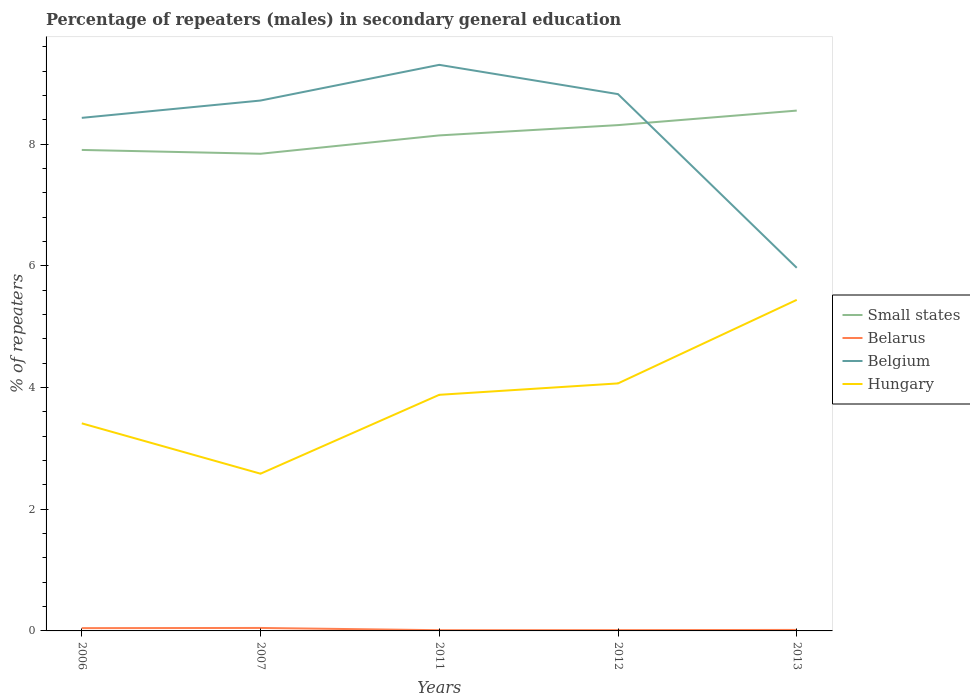Across all years, what is the maximum percentage of male repeaters in Belgium?
Your answer should be very brief. 5.97. In which year was the percentage of male repeaters in Small states maximum?
Make the answer very short. 2007. What is the total percentage of male repeaters in Small states in the graph?
Provide a succinct answer. -0.71. What is the difference between the highest and the second highest percentage of male repeaters in Hungary?
Keep it short and to the point. 2.86. Is the percentage of male repeaters in Belarus strictly greater than the percentage of male repeaters in Belgium over the years?
Ensure brevity in your answer.  Yes. How many lines are there?
Give a very brief answer. 4. What is the difference between two consecutive major ticks on the Y-axis?
Keep it short and to the point. 2. Are the values on the major ticks of Y-axis written in scientific E-notation?
Keep it short and to the point. No. How are the legend labels stacked?
Your response must be concise. Vertical. What is the title of the graph?
Ensure brevity in your answer.  Percentage of repeaters (males) in secondary general education. Does "Lao PDR" appear as one of the legend labels in the graph?
Your response must be concise. No. What is the label or title of the X-axis?
Give a very brief answer. Years. What is the label or title of the Y-axis?
Your response must be concise. % of repeaters. What is the % of repeaters in Small states in 2006?
Offer a terse response. 7.9. What is the % of repeaters of Belarus in 2006?
Offer a terse response. 0.05. What is the % of repeaters in Belgium in 2006?
Make the answer very short. 8.43. What is the % of repeaters of Hungary in 2006?
Give a very brief answer. 3.41. What is the % of repeaters in Small states in 2007?
Give a very brief answer. 7.84. What is the % of repeaters of Belarus in 2007?
Make the answer very short. 0.05. What is the % of repeaters of Belgium in 2007?
Offer a very short reply. 8.72. What is the % of repeaters of Hungary in 2007?
Provide a succinct answer. 2.58. What is the % of repeaters in Small states in 2011?
Keep it short and to the point. 8.14. What is the % of repeaters in Belarus in 2011?
Provide a succinct answer. 0.01. What is the % of repeaters of Belgium in 2011?
Give a very brief answer. 9.3. What is the % of repeaters of Hungary in 2011?
Provide a short and direct response. 3.88. What is the % of repeaters of Small states in 2012?
Provide a short and direct response. 8.31. What is the % of repeaters of Belarus in 2012?
Your response must be concise. 0.01. What is the % of repeaters of Belgium in 2012?
Your answer should be compact. 8.82. What is the % of repeaters in Hungary in 2012?
Offer a very short reply. 4.07. What is the % of repeaters of Small states in 2013?
Your answer should be very brief. 8.55. What is the % of repeaters in Belarus in 2013?
Offer a very short reply. 0.02. What is the % of repeaters in Belgium in 2013?
Your response must be concise. 5.97. What is the % of repeaters in Hungary in 2013?
Provide a succinct answer. 5.44. Across all years, what is the maximum % of repeaters in Small states?
Give a very brief answer. 8.55. Across all years, what is the maximum % of repeaters of Belarus?
Keep it short and to the point. 0.05. Across all years, what is the maximum % of repeaters of Belgium?
Your answer should be very brief. 9.3. Across all years, what is the maximum % of repeaters of Hungary?
Your response must be concise. 5.44. Across all years, what is the minimum % of repeaters of Small states?
Provide a succinct answer. 7.84. Across all years, what is the minimum % of repeaters of Belarus?
Your answer should be very brief. 0.01. Across all years, what is the minimum % of repeaters of Belgium?
Give a very brief answer. 5.97. Across all years, what is the minimum % of repeaters of Hungary?
Provide a short and direct response. 2.58. What is the total % of repeaters of Small states in the graph?
Offer a very short reply. 40.75. What is the total % of repeaters of Belarus in the graph?
Make the answer very short. 0.14. What is the total % of repeaters in Belgium in the graph?
Provide a short and direct response. 41.24. What is the total % of repeaters in Hungary in the graph?
Your response must be concise. 19.38. What is the difference between the % of repeaters of Small states in 2006 and that in 2007?
Your response must be concise. 0.06. What is the difference between the % of repeaters in Belarus in 2006 and that in 2007?
Your answer should be compact. -0. What is the difference between the % of repeaters of Belgium in 2006 and that in 2007?
Provide a short and direct response. -0.28. What is the difference between the % of repeaters of Hungary in 2006 and that in 2007?
Offer a terse response. 0.83. What is the difference between the % of repeaters of Small states in 2006 and that in 2011?
Offer a very short reply. -0.24. What is the difference between the % of repeaters of Belarus in 2006 and that in 2011?
Provide a short and direct response. 0.03. What is the difference between the % of repeaters in Belgium in 2006 and that in 2011?
Make the answer very short. -0.87. What is the difference between the % of repeaters of Hungary in 2006 and that in 2011?
Offer a very short reply. -0.47. What is the difference between the % of repeaters of Small states in 2006 and that in 2012?
Provide a short and direct response. -0.41. What is the difference between the % of repeaters of Belarus in 2006 and that in 2012?
Offer a very short reply. 0.03. What is the difference between the % of repeaters of Belgium in 2006 and that in 2012?
Your response must be concise. -0.39. What is the difference between the % of repeaters of Hungary in 2006 and that in 2012?
Your answer should be compact. -0.66. What is the difference between the % of repeaters in Small states in 2006 and that in 2013?
Provide a succinct answer. -0.65. What is the difference between the % of repeaters of Belarus in 2006 and that in 2013?
Your answer should be compact. 0.03. What is the difference between the % of repeaters in Belgium in 2006 and that in 2013?
Provide a succinct answer. 2.46. What is the difference between the % of repeaters in Hungary in 2006 and that in 2013?
Your answer should be very brief. -2.03. What is the difference between the % of repeaters in Small states in 2007 and that in 2011?
Offer a terse response. -0.3. What is the difference between the % of repeaters in Belarus in 2007 and that in 2011?
Provide a short and direct response. 0.04. What is the difference between the % of repeaters in Belgium in 2007 and that in 2011?
Keep it short and to the point. -0.59. What is the difference between the % of repeaters in Hungary in 2007 and that in 2011?
Offer a terse response. -1.3. What is the difference between the % of repeaters in Small states in 2007 and that in 2012?
Provide a short and direct response. -0.47. What is the difference between the % of repeaters in Belarus in 2007 and that in 2012?
Provide a short and direct response. 0.04. What is the difference between the % of repeaters of Belgium in 2007 and that in 2012?
Your response must be concise. -0.11. What is the difference between the % of repeaters of Hungary in 2007 and that in 2012?
Give a very brief answer. -1.48. What is the difference between the % of repeaters of Small states in 2007 and that in 2013?
Provide a succinct answer. -0.71. What is the difference between the % of repeaters of Belarus in 2007 and that in 2013?
Your answer should be very brief. 0.03. What is the difference between the % of repeaters in Belgium in 2007 and that in 2013?
Ensure brevity in your answer.  2.75. What is the difference between the % of repeaters of Hungary in 2007 and that in 2013?
Provide a succinct answer. -2.86. What is the difference between the % of repeaters of Small states in 2011 and that in 2012?
Provide a short and direct response. -0.17. What is the difference between the % of repeaters of Belarus in 2011 and that in 2012?
Your answer should be compact. -0. What is the difference between the % of repeaters of Belgium in 2011 and that in 2012?
Provide a short and direct response. 0.48. What is the difference between the % of repeaters of Hungary in 2011 and that in 2012?
Keep it short and to the point. -0.19. What is the difference between the % of repeaters in Small states in 2011 and that in 2013?
Your response must be concise. -0.41. What is the difference between the % of repeaters of Belarus in 2011 and that in 2013?
Your answer should be very brief. -0. What is the difference between the % of repeaters in Belgium in 2011 and that in 2013?
Make the answer very short. 3.34. What is the difference between the % of repeaters of Hungary in 2011 and that in 2013?
Your answer should be very brief. -1.56. What is the difference between the % of repeaters of Small states in 2012 and that in 2013?
Give a very brief answer. -0.24. What is the difference between the % of repeaters of Belarus in 2012 and that in 2013?
Ensure brevity in your answer.  -0. What is the difference between the % of repeaters in Belgium in 2012 and that in 2013?
Your response must be concise. 2.85. What is the difference between the % of repeaters of Hungary in 2012 and that in 2013?
Your response must be concise. -1.37. What is the difference between the % of repeaters of Small states in 2006 and the % of repeaters of Belarus in 2007?
Provide a succinct answer. 7.86. What is the difference between the % of repeaters of Small states in 2006 and the % of repeaters of Belgium in 2007?
Provide a short and direct response. -0.81. What is the difference between the % of repeaters of Small states in 2006 and the % of repeaters of Hungary in 2007?
Your response must be concise. 5.32. What is the difference between the % of repeaters in Belarus in 2006 and the % of repeaters in Belgium in 2007?
Offer a very short reply. -8.67. What is the difference between the % of repeaters in Belarus in 2006 and the % of repeaters in Hungary in 2007?
Your response must be concise. -2.54. What is the difference between the % of repeaters in Belgium in 2006 and the % of repeaters in Hungary in 2007?
Keep it short and to the point. 5.85. What is the difference between the % of repeaters in Small states in 2006 and the % of repeaters in Belarus in 2011?
Your answer should be very brief. 7.89. What is the difference between the % of repeaters of Small states in 2006 and the % of repeaters of Belgium in 2011?
Provide a short and direct response. -1.4. What is the difference between the % of repeaters in Small states in 2006 and the % of repeaters in Hungary in 2011?
Make the answer very short. 4.02. What is the difference between the % of repeaters of Belarus in 2006 and the % of repeaters of Belgium in 2011?
Offer a terse response. -9.26. What is the difference between the % of repeaters of Belarus in 2006 and the % of repeaters of Hungary in 2011?
Your answer should be very brief. -3.83. What is the difference between the % of repeaters of Belgium in 2006 and the % of repeaters of Hungary in 2011?
Give a very brief answer. 4.55. What is the difference between the % of repeaters in Small states in 2006 and the % of repeaters in Belarus in 2012?
Your response must be concise. 7.89. What is the difference between the % of repeaters of Small states in 2006 and the % of repeaters of Belgium in 2012?
Provide a short and direct response. -0.92. What is the difference between the % of repeaters in Small states in 2006 and the % of repeaters in Hungary in 2012?
Provide a short and direct response. 3.84. What is the difference between the % of repeaters of Belarus in 2006 and the % of repeaters of Belgium in 2012?
Offer a terse response. -8.78. What is the difference between the % of repeaters in Belarus in 2006 and the % of repeaters in Hungary in 2012?
Your response must be concise. -4.02. What is the difference between the % of repeaters of Belgium in 2006 and the % of repeaters of Hungary in 2012?
Your response must be concise. 4.36. What is the difference between the % of repeaters in Small states in 2006 and the % of repeaters in Belarus in 2013?
Provide a short and direct response. 7.89. What is the difference between the % of repeaters of Small states in 2006 and the % of repeaters of Belgium in 2013?
Provide a succinct answer. 1.94. What is the difference between the % of repeaters of Small states in 2006 and the % of repeaters of Hungary in 2013?
Offer a very short reply. 2.46. What is the difference between the % of repeaters of Belarus in 2006 and the % of repeaters of Belgium in 2013?
Provide a short and direct response. -5.92. What is the difference between the % of repeaters in Belarus in 2006 and the % of repeaters in Hungary in 2013?
Offer a terse response. -5.39. What is the difference between the % of repeaters of Belgium in 2006 and the % of repeaters of Hungary in 2013?
Your response must be concise. 2.99. What is the difference between the % of repeaters of Small states in 2007 and the % of repeaters of Belarus in 2011?
Provide a succinct answer. 7.83. What is the difference between the % of repeaters of Small states in 2007 and the % of repeaters of Belgium in 2011?
Ensure brevity in your answer.  -1.46. What is the difference between the % of repeaters in Small states in 2007 and the % of repeaters in Hungary in 2011?
Your answer should be very brief. 3.96. What is the difference between the % of repeaters in Belarus in 2007 and the % of repeaters in Belgium in 2011?
Ensure brevity in your answer.  -9.25. What is the difference between the % of repeaters in Belarus in 2007 and the % of repeaters in Hungary in 2011?
Your response must be concise. -3.83. What is the difference between the % of repeaters in Belgium in 2007 and the % of repeaters in Hungary in 2011?
Your answer should be compact. 4.84. What is the difference between the % of repeaters in Small states in 2007 and the % of repeaters in Belarus in 2012?
Your response must be concise. 7.83. What is the difference between the % of repeaters in Small states in 2007 and the % of repeaters in Belgium in 2012?
Your response must be concise. -0.98. What is the difference between the % of repeaters of Small states in 2007 and the % of repeaters of Hungary in 2012?
Your answer should be compact. 3.77. What is the difference between the % of repeaters in Belarus in 2007 and the % of repeaters in Belgium in 2012?
Make the answer very short. -8.77. What is the difference between the % of repeaters of Belarus in 2007 and the % of repeaters of Hungary in 2012?
Your answer should be compact. -4.02. What is the difference between the % of repeaters of Belgium in 2007 and the % of repeaters of Hungary in 2012?
Keep it short and to the point. 4.65. What is the difference between the % of repeaters of Small states in 2007 and the % of repeaters of Belarus in 2013?
Your answer should be very brief. 7.82. What is the difference between the % of repeaters in Small states in 2007 and the % of repeaters in Belgium in 2013?
Provide a short and direct response. 1.87. What is the difference between the % of repeaters of Small states in 2007 and the % of repeaters of Hungary in 2013?
Keep it short and to the point. 2.4. What is the difference between the % of repeaters in Belarus in 2007 and the % of repeaters in Belgium in 2013?
Provide a short and direct response. -5.92. What is the difference between the % of repeaters of Belarus in 2007 and the % of repeaters of Hungary in 2013?
Offer a terse response. -5.39. What is the difference between the % of repeaters in Belgium in 2007 and the % of repeaters in Hungary in 2013?
Your answer should be compact. 3.28. What is the difference between the % of repeaters in Small states in 2011 and the % of repeaters in Belarus in 2012?
Your answer should be compact. 8.13. What is the difference between the % of repeaters of Small states in 2011 and the % of repeaters of Belgium in 2012?
Your answer should be compact. -0.68. What is the difference between the % of repeaters in Small states in 2011 and the % of repeaters in Hungary in 2012?
Your answer should be compact. 4.08. What is the difference between the % of repeaters in Belarus in 2011 and the % of repeaters in Belgium in 2012?
Your answer should be compact. -8.81. What is the difference between the % of repeaters in Belarus in 2011 and the % of repeaters in Hungary in 2012?
Provide a succinct answer. -4.06. What is the difference between the % of repeaters in Belgium in 2011 and the % of repeaters in Hungary in 2012?
Your response must be concise. 5.23. What is the difference between the % of repeaters in Small states in 2011 and the % of repeaters in Belarus in 2013?
Ensure brevity in your answer.  8.13. What is the difference between the % of repeaters of Small states in 2011 and the % of repeaters of Belgium in 2013?
Your answer should be compact. 2.18. What is the difference between the % of repeaters of Small states in 2011 and the % of repeaters of Hungary in 2013?
Offer a terse response. 2.7. What is the difference between the % of repeaters of Belarus in 2011 and the % of repeaters of Belgium in 2013?
Offer a terse response. -5.96. What is the difference between the % of repeaters of Belarus in 2011 and the % of repeaters of Hungary in 2013?
Give a very brief answer. -5.43. What is the difference between the % of repeaters of Belgium in 2011 and the % of repeaters of Hungary in 2013?
Your answer should be compact. 3.86. What is the difference between the % of repeaters in Small states in 2012 and the % of repeaters in Belarus in 2013?
Keep it short and to the point. 8.3. What is the difference between the % of repeaters in Small states in 2012 and the % of repeaters in Belgium in 2013?
Give a very brief answer. 2.34. What is the difference between the % of repeaters in Small states in 2012 and the % of repeaters in Hungary in 2013?
Give a very brief answer. 2.87. What is the difference between the % of repeaters of Belarus in 2012 and the % of repeaters of Belgium in 2013?
Ensure brevity in your answer.  -5.95. What is the difference between the % of repeaters of Belarus in 2012 and the % of repeaters of Hungary in 2013?
Offer a terse response. -5.43. What is the difference between the % of repeaters of Belgium in 2012 and the % of repeaters of Hungary in 2013?
Ensure brevity in your answer.  3.38. What is the average % of repeaters of Small states per year?
Your response must be concise. 8.15. What is the average % of repeaters of Belarus per year?
Keep it short and to the point. 0.03. What is the average % of repeaters of Belgium per year?
Offer a very short reply. 8.25. What is the average % of repeaters of Hungary per year?
Give a very brief answer. 3.88. In the year 2006, what is the difference between the % of repeaters in Small states and % of repeaters in Belarus?
Give a very brief answer. 7.86. In the year 2006, what is the difference between the % of repeaters of Small states and % of repeaters of Belgium?
Ensure brevity in your answer.  -0.53. In the year 2006, what is the difference between the % of repeaters of Small states and % of repeaters of Hungary?
Your answer should be very brief. 4.49. In the year 2006, what is the difference between the % of repeaters in Belarus and % of repeaters in Belgium?
Your answer should be compact. -8.39. In the year 2006, what is the difference between the % of repeaters of Belarus and % of repeaters of Hungary?
Provide a succinct answer. -3.37. In the year 2006, what is the difference between the % of repeaters of Belgium and % of repeaters of Hungary?
Provide a succinct answer. 5.02. In the year 2007, what is the difference between the % of repeaters in Small states and % of repeaters in Belarus?
Give a very brief answer. 7.79. In the year 2007, what is the difference between the % of repeaters of Small states and % of repeaters of Belgium?
Offer a terse response. -0.87. In the year 2007, what is the difference between the % of repeaters in Small states and % of repeaters in Hungary?
Offer a terse response. 5.26. In the year 2007, what is the difference between the % of repeaters in Belarus and % of repeaters in Belgium?
Give a very brief answer. -8.67. In the year 2007, what is the difference between the % of repeaters of Belarus and % of repeaters of Hungary?
Your response must be concise. -2.54. In the year 2007, what is the difference between the % of repeaters in Belgium and % of repeaters in Hungary?
Your response must be concise. 6.13. In the year 2011, what is the difference between the % of repeaters of Small states and % of repeaters of Belarus?
Your answer should be very brief. 8.13. In the year 2011, what is the difference between the % of repeaters of Small states and % of repeaters of Belgium?
Offer a terse response. -1.16. In the year 2011, what is the difference between the % of repeaters of Small states and % of repeaters of Hungary?
Keep it short and to the point. 4.26. In the year 2011, what is the difference between the % of repeaters in Belarus and % of repeaters in Belgium?
Your answer should be compact. -9.29. In the year 2011, what is the difference between the % of repeaters in Belarus and % of repeaters in Hungary?
Ensure brevity in your answer.  -3.87. In the year 2011, what is the difference between the % of repeaters in Belgium and % of repeaters in Hungary?
Offer a very short reply. 5.42. In the year 2012, what is the difference between the % of repeaters in Small states and % of repeaters in Belarus?
Your answer should be compact. 8.3. In the year 2012, what is the difference between the % of repeaters of Small states and % of repeaters of Belgium?
Provide a succinct answer. -0.51. In the year 2012, what is the difference between the % of repeaters in Small states and % of repeaters in Hungary?
Your answer should be compact. 4.24. In the year 2012, what is the difference between the % of repeaters in Belarus and % of repeaters in Belgium?
Your response must be concise. -8.81. In the year 2012, what is the difference between the % of repeaters of Belarus and % of repeaters of Hungary?
Keep it short and to the point. -4.05. In the year 2012, what is the difference between the % of repeaters in Belgium and % of repeaters in Hungary?
Ensure brevity in your answer.  4.75. In the year 2013, what is the difference between the % of repeaters in Small states and % of repeaters in Belarus?
Offer a terse response. 8.53. In the year 2013, what is the difference between the % of repeaters in Small states and % of repeaters in Belgium?
Your response must be concise. 2.58. In the year 2013, what is the difference between the % of repeaters of Small states and % of repeaters of Hungary?
Your answer should be compact. 3.11. In the year 2013, what is the difference between the % of repeaters of Belarus and % of repeaters of Belgium?
Provide a succinct answer. -5.95. In the year 2013, what is the difference between the % of repeaters in Belarus and % of repeaters in Hungary?
Your answer should be very brief. -5.42. In the year 2013, what is the difference between the % of repeaters of Belgium and % of repeaters of Hungary?
Ensure brevity in your answer.  0.53. What is the ratio of the % of repeaters in Belarus in 2006 to that in 2007?
Provide a succinct answer. 0.94. What is the ratio of the % of repeaters of Belgium in 2006 to that in 2007?
Provide a short and direct response. 0.97. What is the ratio of the % of repeaters of Hungary in 2006 to that in 2007?
Give a very brief answer. 1.32. What is the ratio of the % of repeaters of Small states in 2006 to that in 2011?
Provide a short and direct response. 0.97. What is the ratio of the % of repeaters in Belarus in 2006 to that in 2011?
Keep it short and to the point. 3.91. What is the ratio of the % of repeaters of Belgium in 2006 to that in 2011?
Your answer should be very brief. 0.91. What is the ratio of the % of repeaters in Hungary in 2006 to that in 2011?
Make the answer very short. 0.88. What is the ratio of the % of repeaters of Small states in 2006 to that in 2012?
Make the answer very short. 0.95. What is the ratio of the % of repeaters of Belarus in 2006 to that in 2012?
Give a very brief answer. 3.57. What is the ratio of the % of repeaters of Belgium in 2006 to that in 2012?
Your answer should be very brief. 0.96. What is the ratio of the % of repeaters of Hungary in 2006 to that in 2012?
Offer a very short reply. 0.84. What is the ratio of the % of repeaters in Small states in 2006 to that in 2013?
Offer a terse response. 0.92. What is the ratio of the % of repeaters in Belarus in 2006 to that in 2013?
Your response must be concise. 2.82. What is the ratio of the % of repeaters of Belgium in 2006 to that in 2013?
Your answer should be very brief. 1.41. What is the ratio of the % of repeaters in Hungary in 2006 to that in 2013?
Provide a short and direct response. 0.63. What is the ratio of the % of repeaters in Belarus in 2007 to that in 2011?
Ensure brevity in your answer.  4.14. What is the ratio of the % of repeaters in Belgium in 2007 to that in 2011?
Your answer should be very brief. 0.94. What is the ratio of the % of repeaters in Hungary in 2007 to that in 2011?
Provide a succinct answer. 0.67. What is the ratio of the % of repeaters of Small states in 2007 to that in 2012?
Provide a short and direct response. 0.94. What is the ratio of the % of repeaters in Belarus in 2007 to that in 2012?
Your answer should be very brief. 3.78. What is the ratio of the % of repeaters in Hungary in 2007 to that in 2012?
Keep it short and to the point. 0.64. What is the ratio of the % of repeaters in Small states in 2007 to that in 2013?
Provide a short and direct response. 0.92. What is the ratio of the % of repeaters in Belarus in 2007 to that in 2013?
Provide a succinct answer. 2.98. What is the ratio of the % of repeaters in Belgium in 2007 to that in 2013?
Ensure brevity in your answer.  1.46. What is the ratio of the % of repeaters in Hungary in 2007 to that in 2013?
Your answer should be very brief. 0.47. What is the ratio of the % of repeaters of Small states in 2011 to that in 2012?
Ensure brevity in your answer.  0.98. What is the ratio of the % of repeaters in Belarus in 2011 to that in 2012?
Ensure brevity in your answer.  0.91. What is the ratio of the % of repeaters in Belgium in 2011 to that in 2012?
Ensure brevity in your answer.  1.05. What is the ratio of the % of repeaters of Hungary in 2011 to that in 2012?
Offer a terse response. 0.95. What is the ratio of the % of repeaters in Small states in 2011 to that in 2013?
Make the answer very short. 0.95. What is the ratio of the % of repeaters of Belarus in 2011 to that in 2013?
Make the answer very short. 0.72. What is the ratio of the % of repeaters of Belgium in 2011 to that in 2013?
Your response must be concise. 1.56. What is the ratio of the % of repeaters in Hungary in 2011 to that in 2013?
Your answer should be very brief. 0.71. What is the ratio of the % of repeaters in Small states in 2012 to that in 2013?
Give a very brief answer. 0.97. What is the ratio of the % of repeaters of Belarus in 2012 to that in 2013?
Keep it short and to the point. 0.79. What is the ratio of the % of repeaters in Belgium in 2012 to that in 2013?
Offer a terse response. 1.48. What is the ratio of the % of repeaters of Hungary in 2012 to that in 2013?
Provide a succinct answer. 0.75. What is the difference between the highest and the second highest % of repeaters in Small states?
Offer a very short reply. 0.24. What is the difference between the highest and the second highest % of repeaters of Belarus?
Offer a terse response. 0. What is the difference between the highest and the second highest % of repeaters of Belgium?
Provide a succinct answer. 0.48. What is the difference between the highest and the second highest % of repeaters of Hungary?
Offer a very short reply. 1.37. What is the difference between the highest and the lowest % of repeaters in Small states?
Your response must be concise. 0.71. What is the difference between the highest and the lowest % of repeaters of Belarus?
Offer a very short reply. 0.04. What is the difference between the highest and the lowest % of repeaters of Belgium?
Make the answer very short. 3.34. What is the difference between the highest and the lowest % of repeaters of Hungary?
Provide a short and direct response. 2.86. 